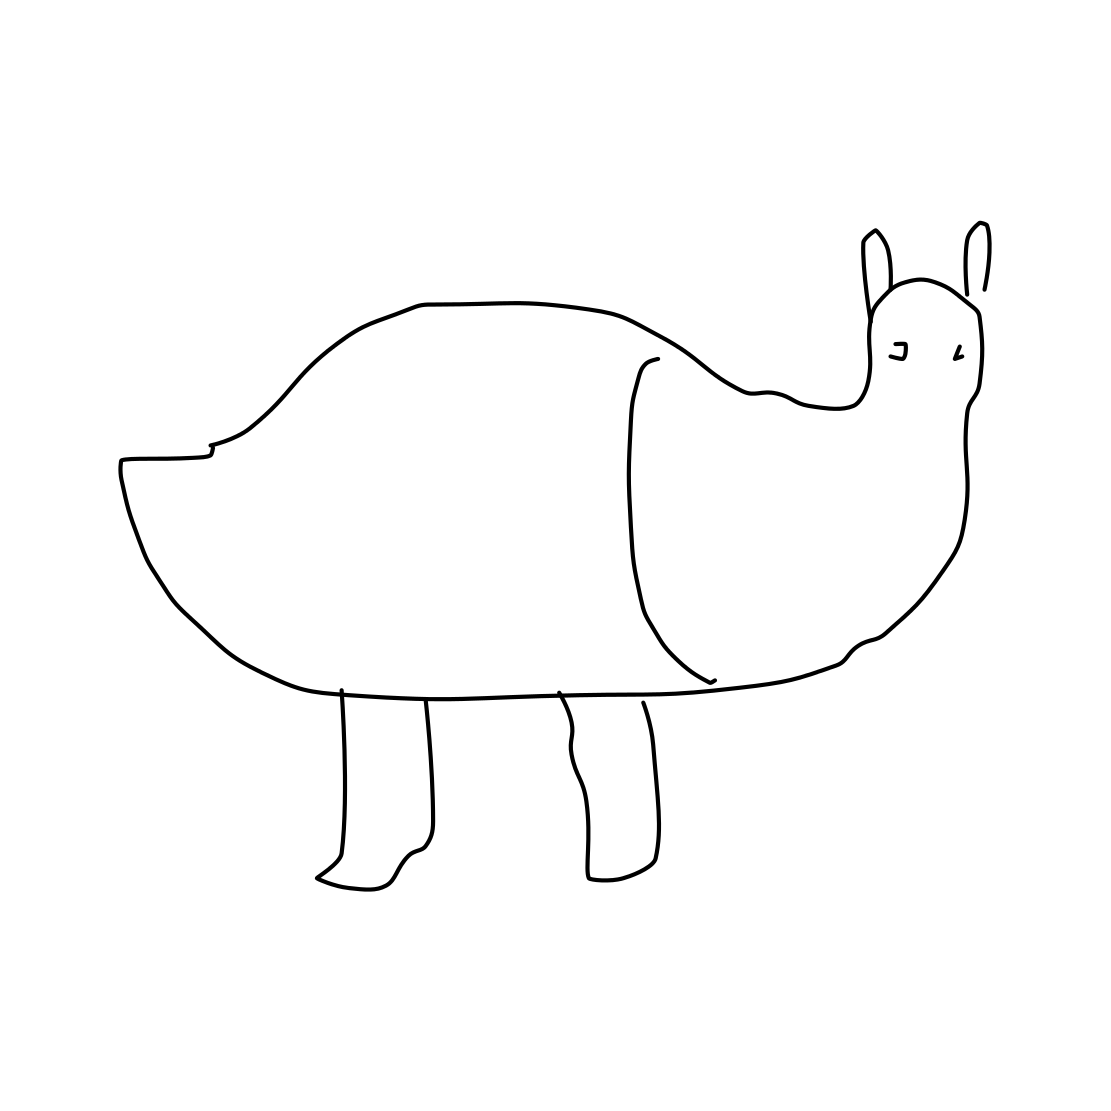What kind of artistic style is represented in this drawing? This drawing illustrates a minimalist and abstract style, characterized by simple lines and lack of detail. It embraces abstract representation over realistic depiction, which leaves much to interpretation. The artist has reduced the subject to its most basic form and shape, which may evoke different responses from viewers. Could this be considered good art? Art is very subjective, and what is considered 'good' can greatly differ from person to person. Minimalist and abstract art styles, such as the one shown in this drawing, are appreciated for their simplicity and ability to capture the essence of a subject with very few strokes. It can be considered good art if it evokes thought, emotion, or a sense of aesthetic pleasure. 